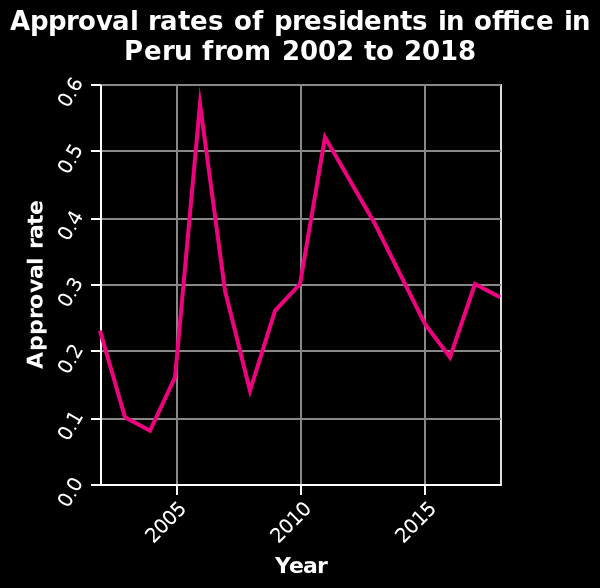<image>
What is measured on the x-axis of the line chart?  The x-axis of the line chart measures Year on a linear scale, with a minimum of 2005 and a maximum of 2015. What is shown on the y-axis of the line chart?  The y-axis of the line chart shows Approval rate on a scale ranging from 0.0 to 0.6. In which year was the lowest approval rate recorded?  The lowest approval rate, below 0.1, was recorded in 2004. What is the range of the Approval rate on the y-axis of the line chart? The Approval rate on the y-axis ranges from 0.0 to 0.6. What is the period covered by the line chart?  The line chart covers the period from 2002 to 2018. What was the difference between the highest and lowest approval rates? The difference between the highest approval rate (0.6 in 2007) and the lowest approval rate (below 0.1 in 2004) is significant. 